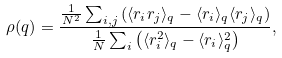<formula> <loc_0><loc_0><loc_500><loc_500>\rho ( q ) = \frac { \frac { 1 } { N ^ { 2 } } \sum _ { i , j } \left ( \langle r _ { i } r _ { j } \rangle _ { q } - \langle r _ { i } \rangle _ { q } \langle r _ { j } \rangle _ { q } \right ) } { \frac { 1 } { N } \sum _ { i } \left ( \langle r _ { i } ^ { 2 } \rangle _ { q } - \langle r _ { i } \rangle _ { q } ^ { 2 } \right ) } ,</formula> 